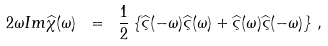Convert formula to latex. <formula><loc_0><loc_0><loc_500><loc_500>2 \omega I m \widehat { \chi } ( \omega ) \ = \ \frac { 1 } { 2 } \left \{ \widehat { \varsigma } ( - \omega ) \widehat { \varsigma } ( \omega ) + \widehat { \varsigma } ( \omega ) \widehat { \varsigma } ( - \omega ) \right \} \, ,</formula> 